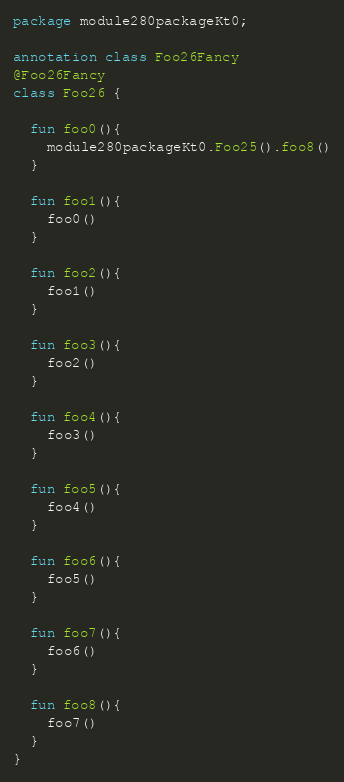Convert code to text. <code><loc_0><loc_0><loc_500><loc_500><_Kotlin_>package module280packageKt0;

annotation class Foo26Fancy
@Foo26Fancy
class Foo26 {

  fun foo0(){
    module280packageKt0.Foo25().foo8()
  }

  fun foo1(){
    foo0()
  }

  fun foo2(){
    foo1()
  }

  fun foo3(){
    foo2()
  }

  fun foo4(){
    foo3()
  }

  fun foo5(){
    foo4()
  }

  fun foo6(){
    foo5()
  }

  fun foo7(){
    foo6()
  }

  fun foo8(){
    foo7()
  }
}</code> 